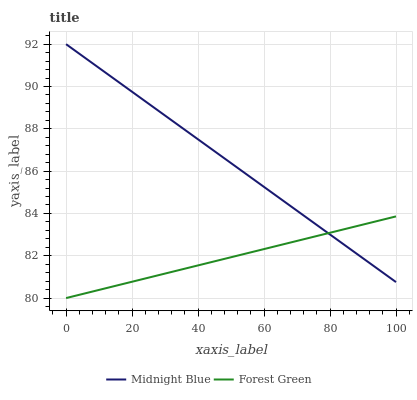Does Forest Green have the minimum area under the curve?
Answer yes or no. Yes. Does Midnight Blue have the maximum area under the curve?
Answer yes or no. Yes. Does Midnight Blue have the minimum area under the curve?
Answer yes or no. No. Is Midnight Blue the smoothest?
Answer yes or no. Yes. Is Forest Green the roughest?
Answer yes or no. Yes. Is Midnight Blue the roughest?
Answer yes or no. No. Does Forest Green have the lowest value?
Answer yes or no. Yes. Does Midnight Blue have the lowest value?
Answer yes or no. No. Does Midnight Blue have the highest value?
Answer yes or no. Yes. Does Midnight Blue intersect Forest Green?
Answer yes or no. Yes. Is Midnight Blue less than Forest Green?
Answer yes or no. No. Is Midnight Blue greater than Forest Green?
Answer yes or no. No. 